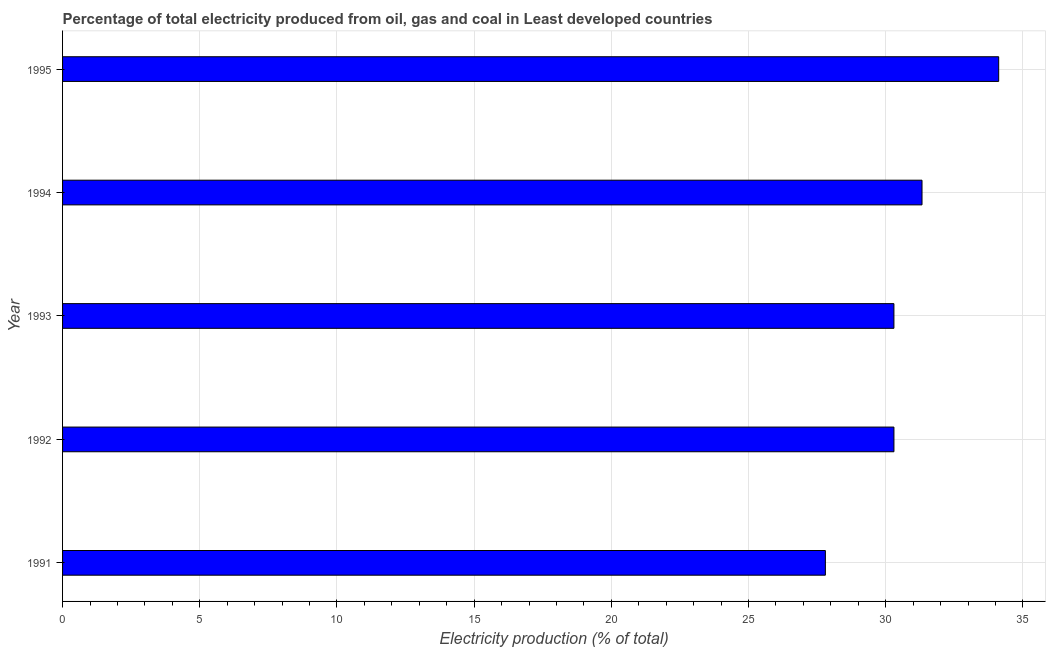Does the graph contain any zero values?
Give a very brief answer. No. Does the graph contain grids?
Offer a very short reply. Yes. What is the title of the graph?
Keep it short and to the point. Percentage of total electricity produced from oil, gas and coal in Least developed countries. What is the label or title of the X-axis?
Ensure brevity in your answer.  Electricity production (% of total). What is the electricity production in 1995?
Keep it short and to the point. 34.12. Across all years, what is the maximum electricity production?
Your response must be concise. 34.12. Across all years, what is the minimum electricity production?
Keep it short and to the point. 27.8. In which year was the electricity production maximum?
Provide a succinct answer. 1995. In which year was the electricity production minimum?
Offer a very short reply. 1991. What is the sum of the electricity production?
Make the answer very short. 153.84. What is the difference between the electricity production in 1992 and 1993?
Offer a very short reply. 0. What is the average electricity production per year?
Ensure brevity in your answer.  30.77. What is the median electricity production?
Your response must be concise. 30.3. What is the ratio of the electricity production in 1994 to that in 1995?
Your answer should be very brief. 0.92. Is the electricity production in 1991 less than that in 1993?
Make the answer very short. Yes. Is the difference between the electricity production in 1991 and 1995 greater than the difference between any two years?
Offer a very short reply. Yes. What is the difference between the highest and the second highest electricity production?
Provide a short and direct response. 2.79. Is the sum of the electricity production in 1991 and 1995 greater than the maximum electricity production across all years?
Offer a very short reply. Yes. What is the difference between the highest and the lowest electricity production?
Give a very brief answer. 6.32. How many bars are there?
Make the answer very short. 5. Are all the bars in the graph horizontal?
Your answer should be compact. Yes. How many years are there in the graph?
Provide a short and direct response. 5. Are the values on the major ticks of X-axis written in scientific E-notation?
Ensure brevity in your answer.  No. What is the Electricity production (% of total) of 1991?
Provide a short and direct response. 27.8. What is the Electricity production (% of total) in 1992?
Make the answer very short. 30.3. What is the Electricity production (% of total) in 1993?
Your answer should be very brief. 30.3. What is the Electricity production (% of total) in 1994?
Provide a succinct answer. 31.32. What is the Electricity production (% of total) of 1995?
Keep it short and to the point. 34.12. What is the difference between the Electricity production (% of total) in 1991 and 1992?
Provide a succinct answer. -2.5. What is the difference between the Electricity production (% of total) in 1991 and 1993?
Make the answer very short. -2.5. What is the difference between the Electricity production (% of total) in 1991 and 1994?
Provide a short and direct response. -3.52. What is the difference between the Electricity production (% of total) in 1991 and 1995?
Your response must be concise. -6.32. What is the difference between the Electricity production (% of total) in 1992 and 1993?
Give a very brief answer. 0. What is the difference between the Electricity production (% of total) in 1992 and 1994?
Your answer should be compact. -1.02. What is the difference between the Electricity production (% of total) in 1992 and 1995?
Keep it short and to the point. -3.82. What is the difference between the Electricity production (% of total) in 1993 and 1994?
Ensure brevity in your answer.  -1.02. What is the difference between the Electricity production (% of total) in 1993 and 1995?
Make the answer very short. -3.82. What is the difference between the Electricity production (% of total) in 1994 and 1995?
Offer a terse response. -2.79. What is the ratio of the Electricity production (% of total) in 1991 to that in 1992?
Offer a terse response. 0.92. What is the ratio of the Electricity production (% of total) in 1991 to that in 1993?
Provide a short and direct response. 0.92. What is the ratio of the Electricity production (% of total) in 1991 to that in 1994?
Offer a very short reply. 0.89. What is the ratio of the Electricity production (% of total) in 1991 to that in 1995?
Your response must be concise. 0.81. What is the ratio of the Electricity production (% of total) in 1992 to that in 1993?
Provide a short and direct response. 1. What is the ratio of the Electricity production (% of total) in 1992 to that in 1995?
Ensure brevity in your answer.  0.89. What is the ratio of the Electricity production (% of total) in 1993 to that in 1995?
Offer a terse response. 0.89. What is the ratio of the Electricity production (% of total) in 1994 to that in 1995?
Your answer should be very brief. 0.92. 